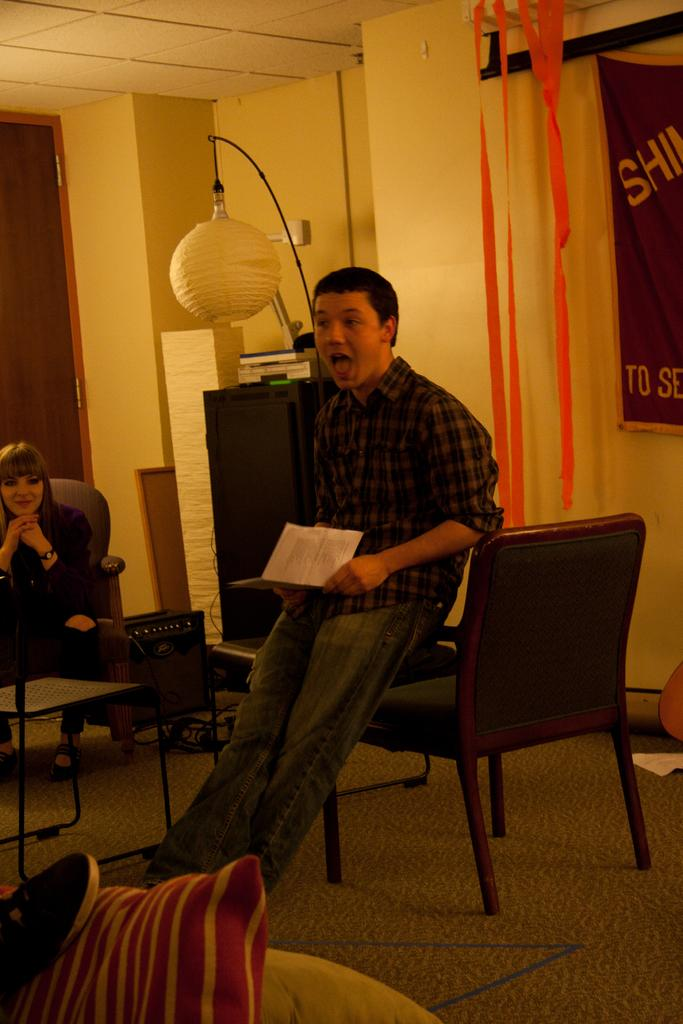What is the person in the image doing? The person is sitting in the image and holding papers. Can you describe the person's gender? The person is a woman. What is the woman's expression in the image? The woman is smiling. What can be seen in the background of the image? There is a wall in the image. What type of flowers can be seen growing on the wall in the image? There are no flowers visible in the image; the background only shows a wall. 